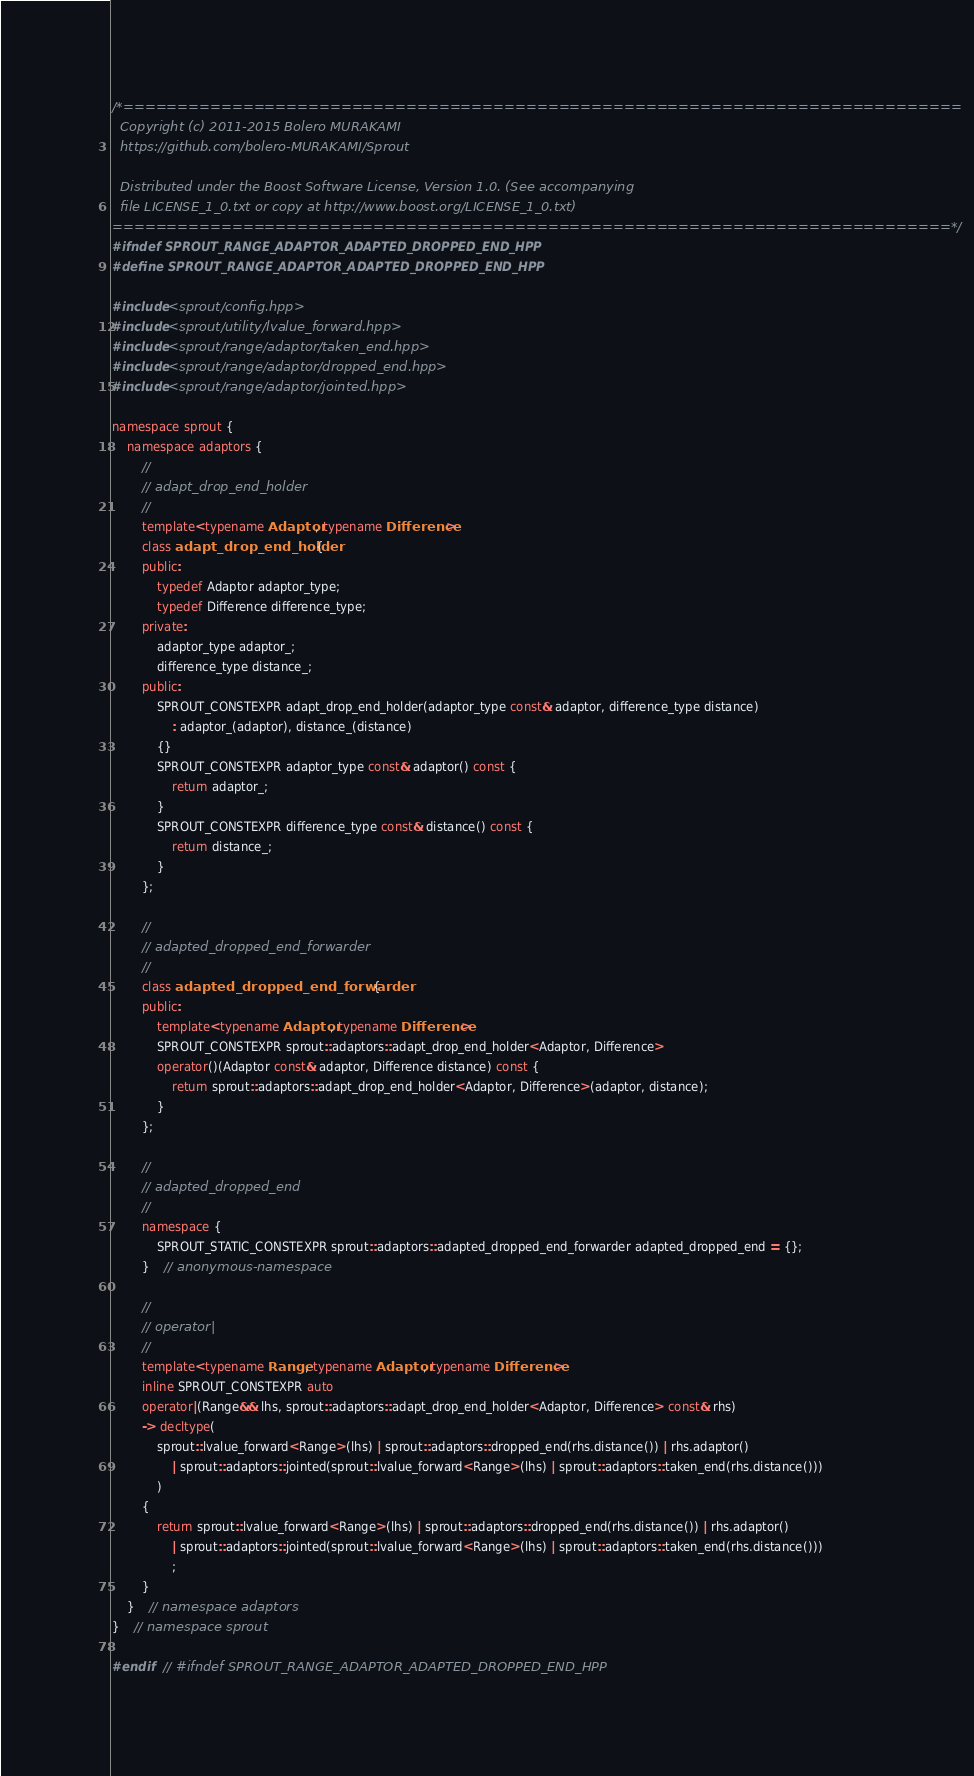Convert code to text. <code><loc_0><loc_0><loc_500><loc_500><_C++_>/*=============================================================================
  Copyright (c) 2011-2015 Bolero MURAKAMI
  https://github.com/bolero-MURAKAMI/Sprout

  Distributed under the Boost Software License, Version 1.0. (See accompanying
  file LICENSE_1_0.txt or copy at http://www.boost.org/LICENSE_1_0.txt)
=============================================================================*/
#ifndef SPROUT_RANGE_ADAPTOR_ADAPTED_DROPPED_END_HPP
#define SPROUT_RANGE_ADAPTOR_ADAPTED_DROPPED_END_HPP

#include <sprout/config.hpp>
#include <sprout/utility/lvalue_forward.hpp>
#include <sprout/range/adaptor/taken_end.hpp>
#include <sprout/range/adaptor/dropped_end.hpp>
#include <sprout/range/adaptor/jointed.hpp>

namespace sprout {
	namespace adaptors {
		//
		// adapt_drop_end_holder
		//
		template<typename Adaptor, typename Difference>
		class adapt_drop_end_holder {
		public:
			typedef Adaptor adaptor_type;
			typedef Difference difference_type;
		private:
			adaptor_type adaptor_;
			difference_type distance_;
		public:
			SPROUT_CONSTEXPR adapt_drop_end_holder(adaptor_type const& adaptor, difference_type distance)
				: adaptor_(adaptor), distance_(distance)
			{}
			SPROUT_CONSTEXPR adaptor_type const& adaptor() const {
				return adaptor_;
			}
			SPROUT_CONSTEXPR difference_type const& distance() const {
				return distance_;
			}
		};

		//
		// adapted_dropped_end_forwarder
		//
		class adapted_dropped_end_forwarder {
		public:
			template<typename Adaptor, typename Difference>
			SPROUT_CONSTEXPR sprout::adaptors::adapt_drop_end_holder<Adaptor, Difference>
			operator()(Adaptor const& adaptor, Difference distance) const {
				return sprout::adaptors::adapt_drop_end_holder<Adaptor, Difference>(adaptor, distance);
			}
		};

		//
		// adapted_dropped_end
		//
		namespace {
			SPROUT_STATIC_CONSTEXPR sprout::adaptors::adapted_dropped_end_forwarder adapted_dropped_end = {};
		}	// anonymous-namespace

		//
		// operator|
		//
		template<typename Range, typename Adaptor, typename Difference>
		inline SPROUT_CONSTEXPR auto
		operator|(Range&& lhs, sprout::adaptors::adapt_drop_end_holder<Adaptor, Difference> const& rhs)
		-> decltype(
			sprout::lvalue_forward<Range>(lhs) | sprout::adaptors::dropped_end(rhs.distance()) | rhs.adaptor()
				| sprout::adaptors::jointed(sprout::lvalue_forward<Range>(lhs) | sprout::adaptors::taken_end(rhs.distance()))
			)
		{
			return sprout::lvalue_forward<Range>(lhs) | sprout::adaptors::dropped_end(rhs.distance()) | rhs.adaptor()
				| sprout::adaptors::jointed(sprout::lvalue_forward<Range>(lhs) | sprout::adaptors::taken_end(rhs.distance()))
				;
		}
	}	// namespace adaptors
}	// namespace sprout

#endif	// #ifndef SPROUT_RANGE_ADAPTOR_ADAPTED_DROPPED_END_HPP
</code> 